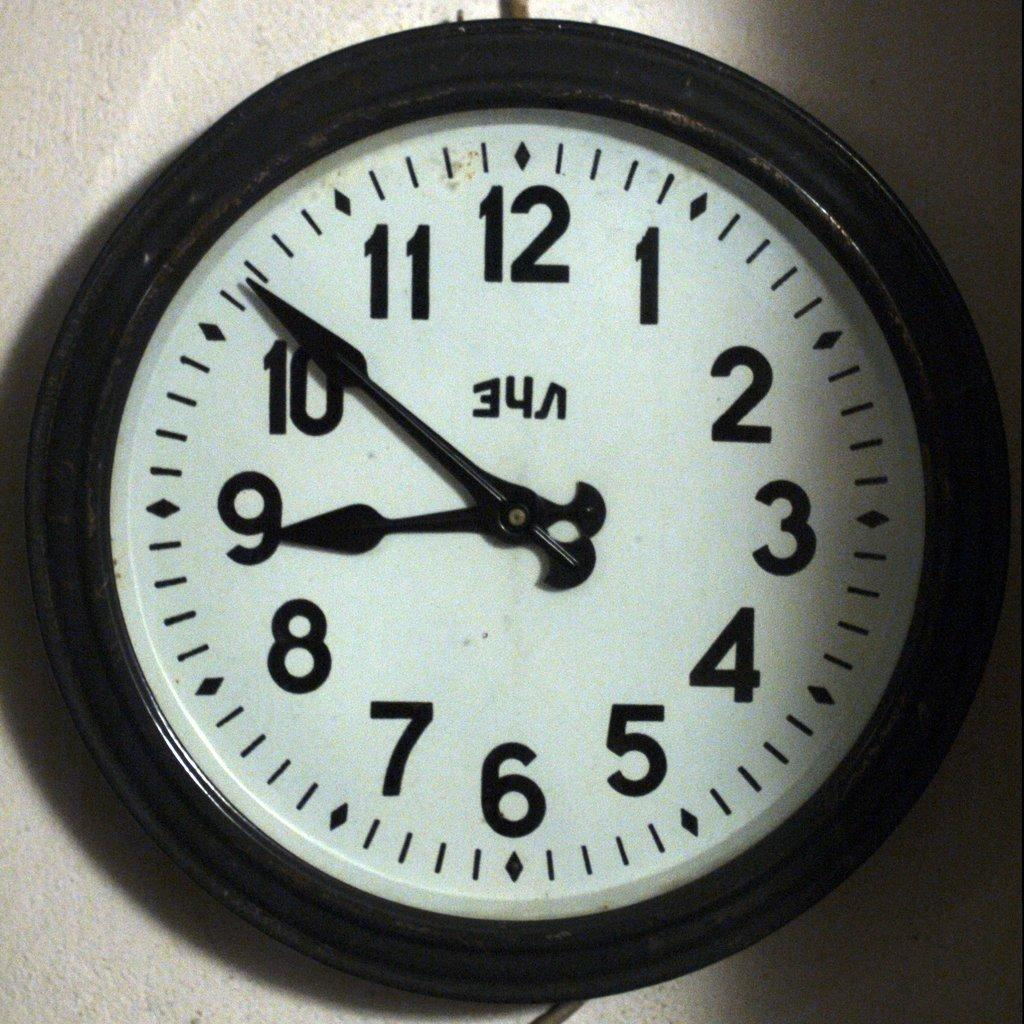<image>
Provide a brief description of the given image. the numbers 1 thru 12 are on a clock 